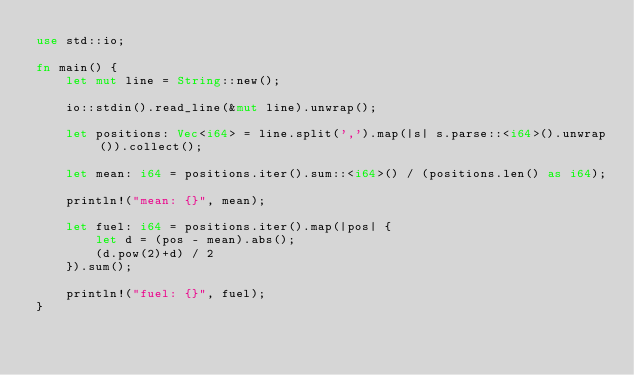<code> <loc_0><loc_0><loc_500><loc_500><_Rust_>use std::io;

fn main() {
    let mut line = String::new();

    io::stdin().read_line(&mut line).unwrap();

    let positions: Vec<i64> = line.split(',').map(|s| s.parse::<i64>().unwrap()).collect();

    let mean: i64 = positions.iter().sum::<i64>() / (positions.len() as i64);

    println!("mean: {}", mean);

    let fuel: i64 = positions.iter().map(|pos| {
        let d = (pos - mean).abs();
        (d.pow(2)+d) / 2
    }).sum();

    println!("fuel: {}", fuel);
}
</code> 